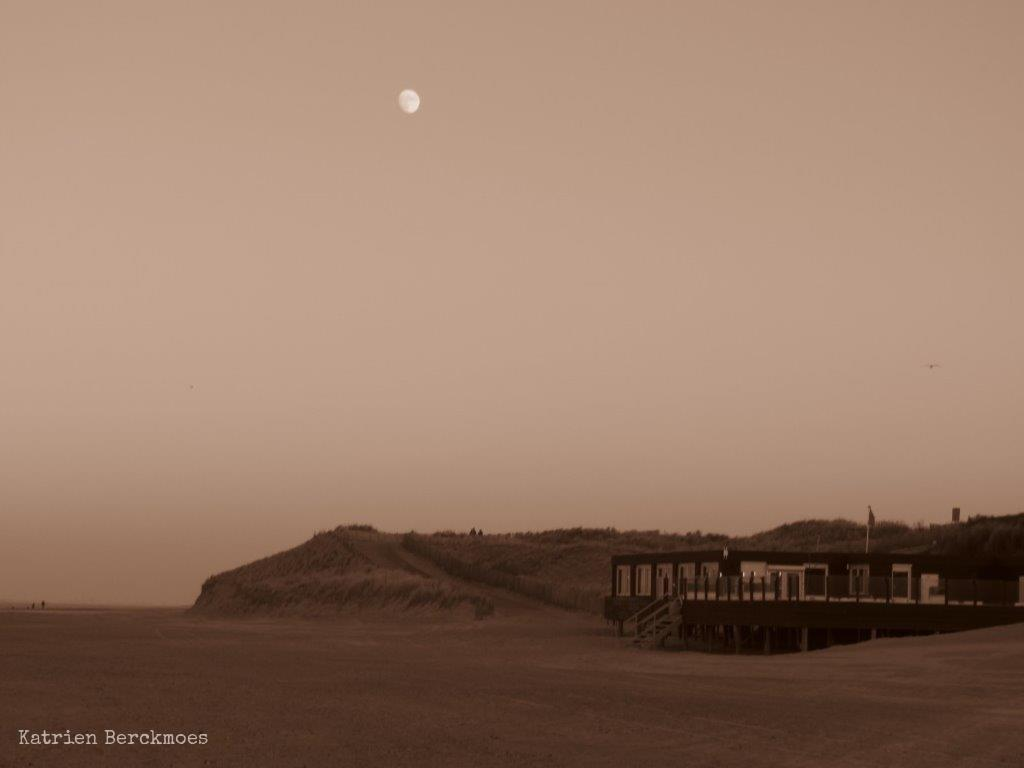What type of structure is present in the image? There is a building in the image. What is located beside the building? There is a hill beside the building. What celestial body can be seen in the sky at the top of the image? The moon is visible in the sky at the top of the image. How many snakes are slithering on the rail in the image? There are no snakes or rails present in the image. 